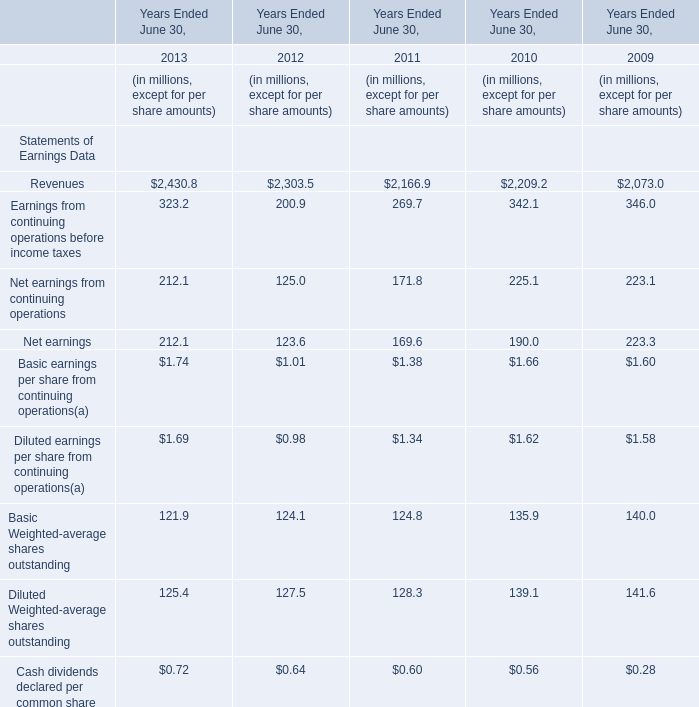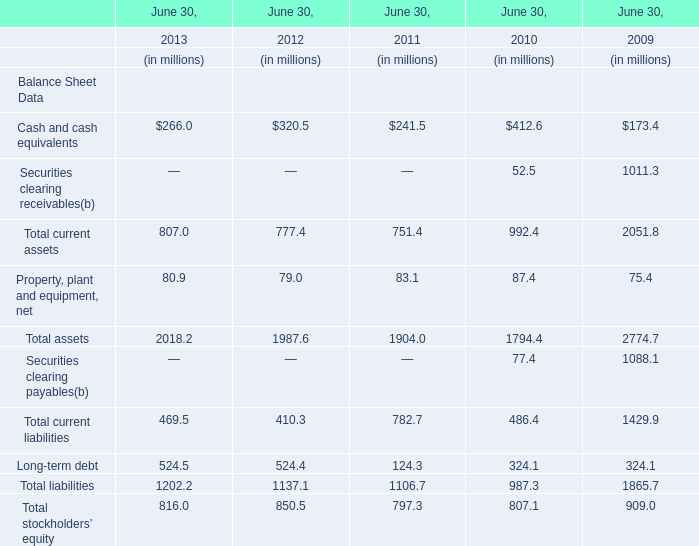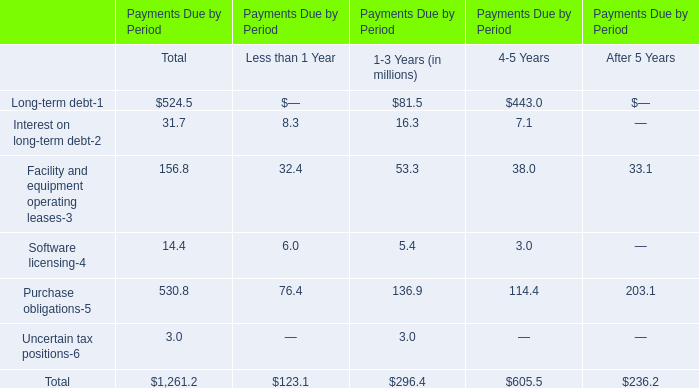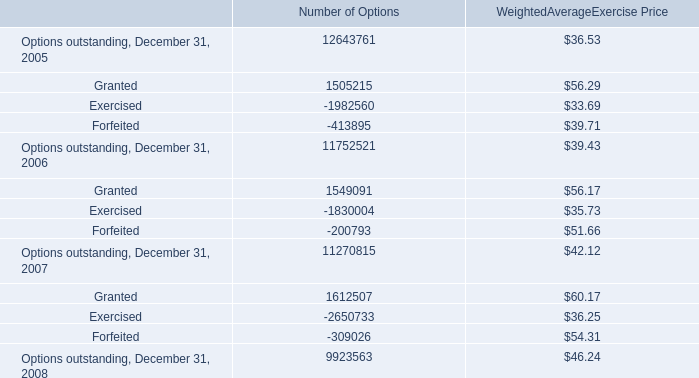What's the difference of Revenues between 2013 and 2012? (in millions) 
Computations: (2430.8 - 2303.5)
Answer: 127.3. 